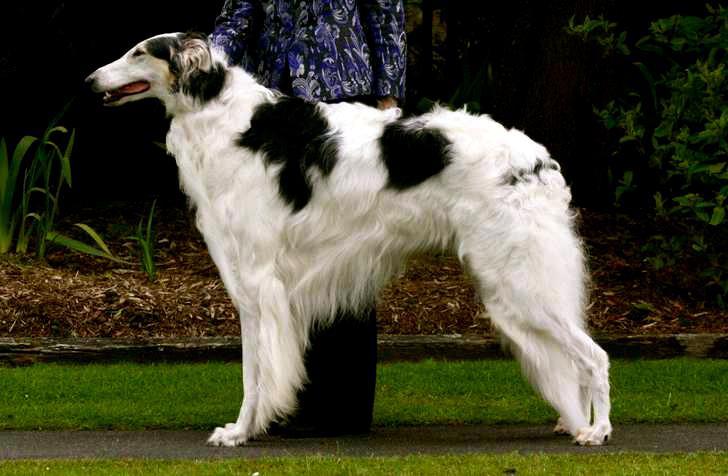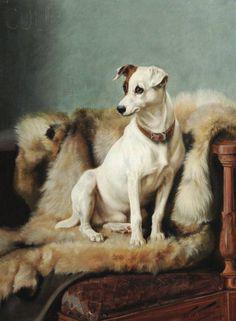The first image is the image on the left, the second image is the image on the right. Evaluate the accuracy of this statement regarding the images: "The right image contains a painting with two dogs.". Is it true? Answer yes or no. No. The first image is the image on the left, the second image is the image on the right. Evaluate the accuracy of this statement regarding the images: "In one image there is a lone Russian Wolfhound standing with its nose pointing to the left of the image.". Is it true? Answer yes or no. Yes. 